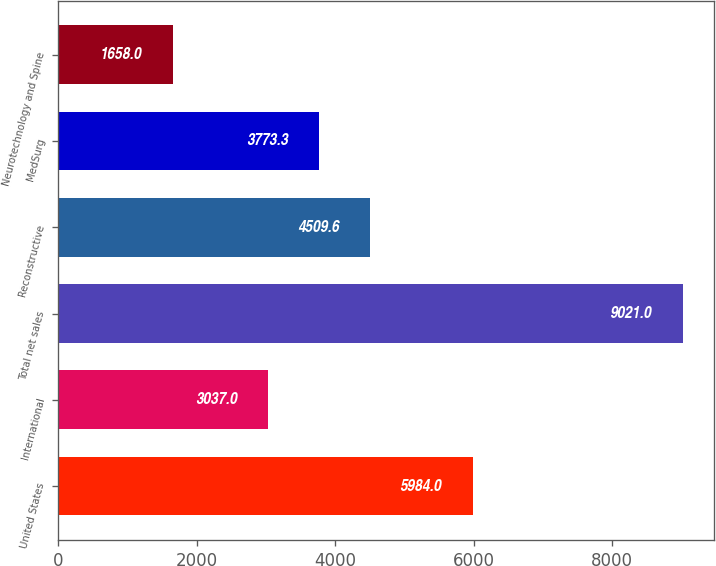Convert chart to OTSL. <chart><loc_0><loc_0><loc_500><loc_500><bar_chart><fcel>United States<fcel>International<fcel>Total net sales<fcel>Reconstructive<fcel>MedSurg<fcel>Neurotechnology and Spine<nl><fcel>5984<fcel>3037<fcel>9021<fcel>4509.6<fcel>3773.3<fcel>1658<nl></chart> 